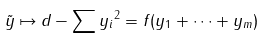Convert formula to latex. <formula><loc_0><loc_0><loc_500><loc_500>\tilde { y } \mapsto \| d - \sum y _ { i } \| ^ { 2 } = f ( y _ { 1 } + \cdots + y _ { m } )</formula> 